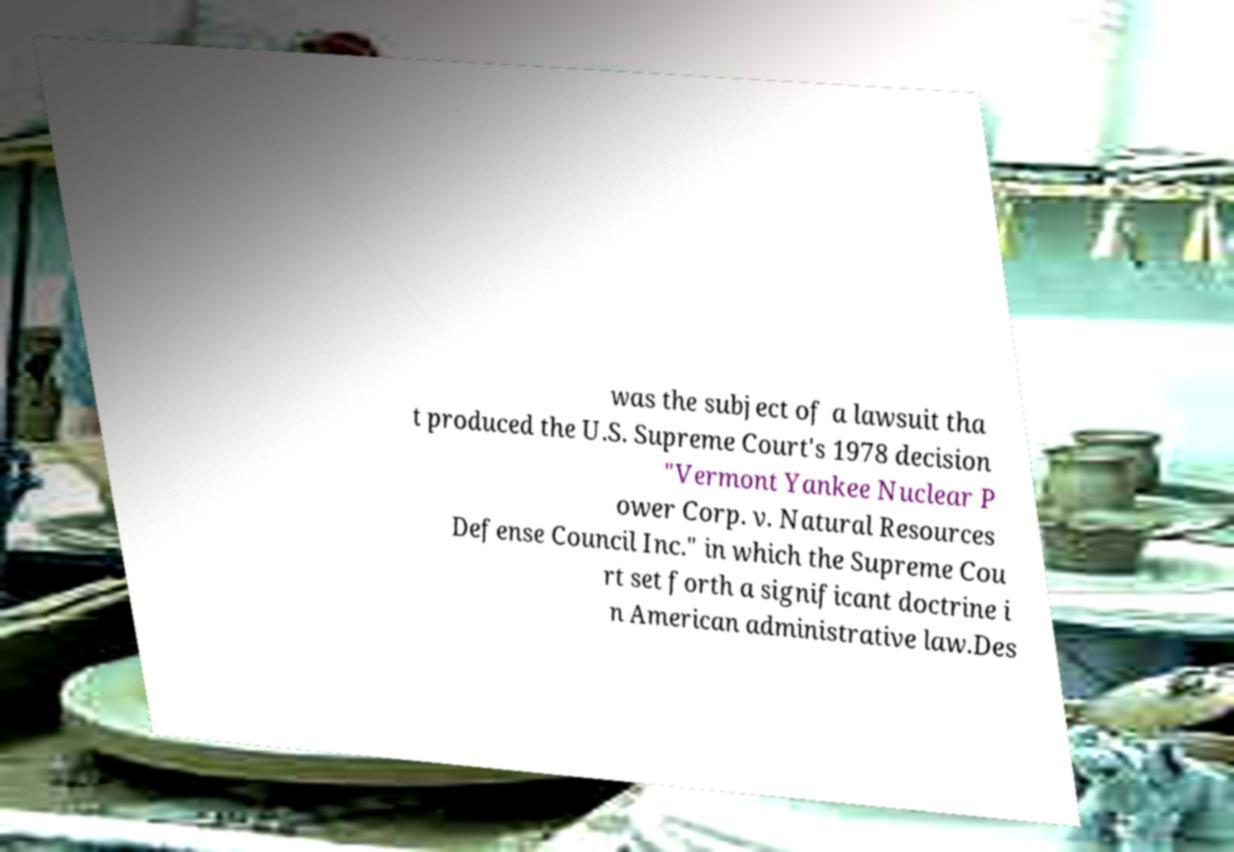Could you assist in decoding the text presented in this image and type it out clearly? was the subject of a lawsuit tha t produced the U.S. Supreme Court's 1978 decision "Vermont Yankee Nuclear P ower Corp. v. Natural Resources Defense Council Inc." in which the Supreme Cou rt set forth a significant doctrine i n American administrative law.Des 